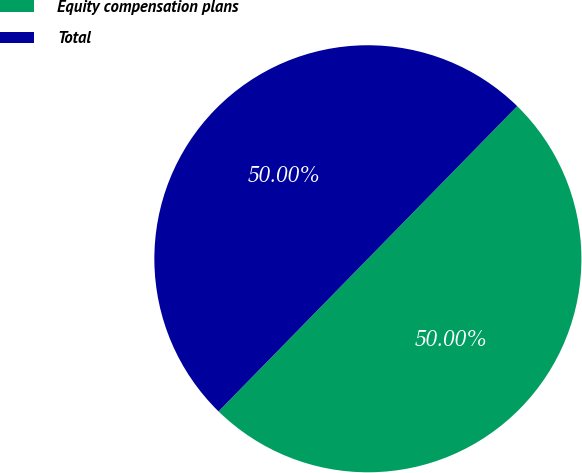<chart> <loc_0><loc_0><loc_500><loc_500><pie_chart><fcel>Equity compensation plans<fcel>Total<nl><fcel>50.0%<fcel>50.0%<nl></chart> 